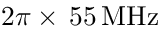Convert formula to latex. <formula><loc_0><loc_0><loc_500><loc_500>2 \pi \times \, 5 5 \, M H z</formula> 